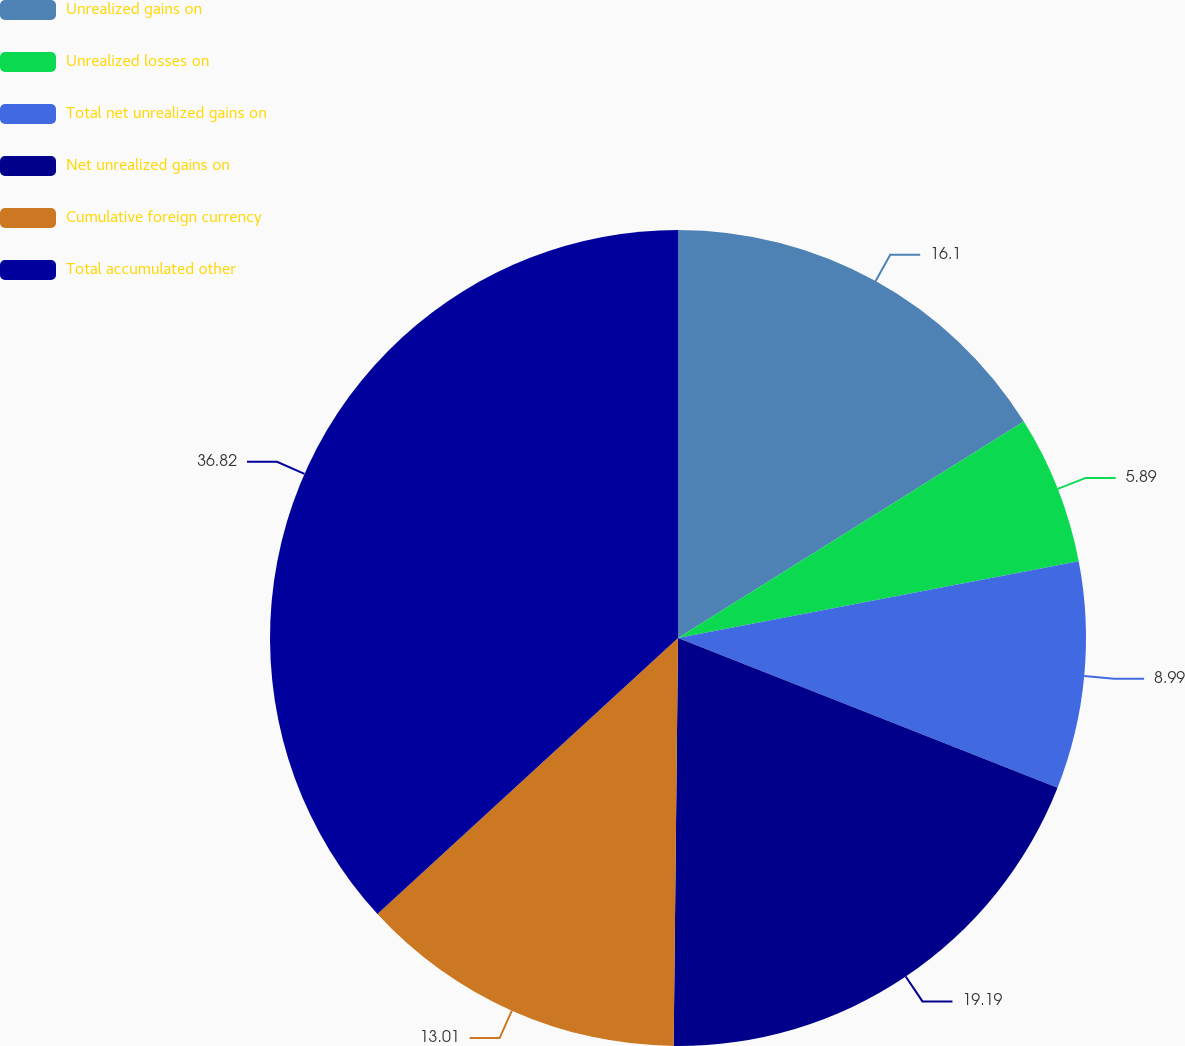<chart> <loc_0><loc_0><loc_500><loc_500><pie_chart><fcel>Unrealized gains on<fcel>Unrealized losses on<fcel>Total net unrealized gains on<fcel>Net unrealized gains on<fcel>Cumulative foreign currency<fcel>Total accumulated other<nl><fcel>16.1%<fcel>5.89%<fcel>8.99%<fcel>19.19%<fcel>13.01%<fcel>36.82%<nl></chart> 